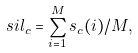Convert formula to latex. <formula><loc_0><loc_0><loc_500><loc_500>s i l _ { c } = \sum _ { i = 1 } ^ { M } s _ { c } ( i ) / M ,</formula> 